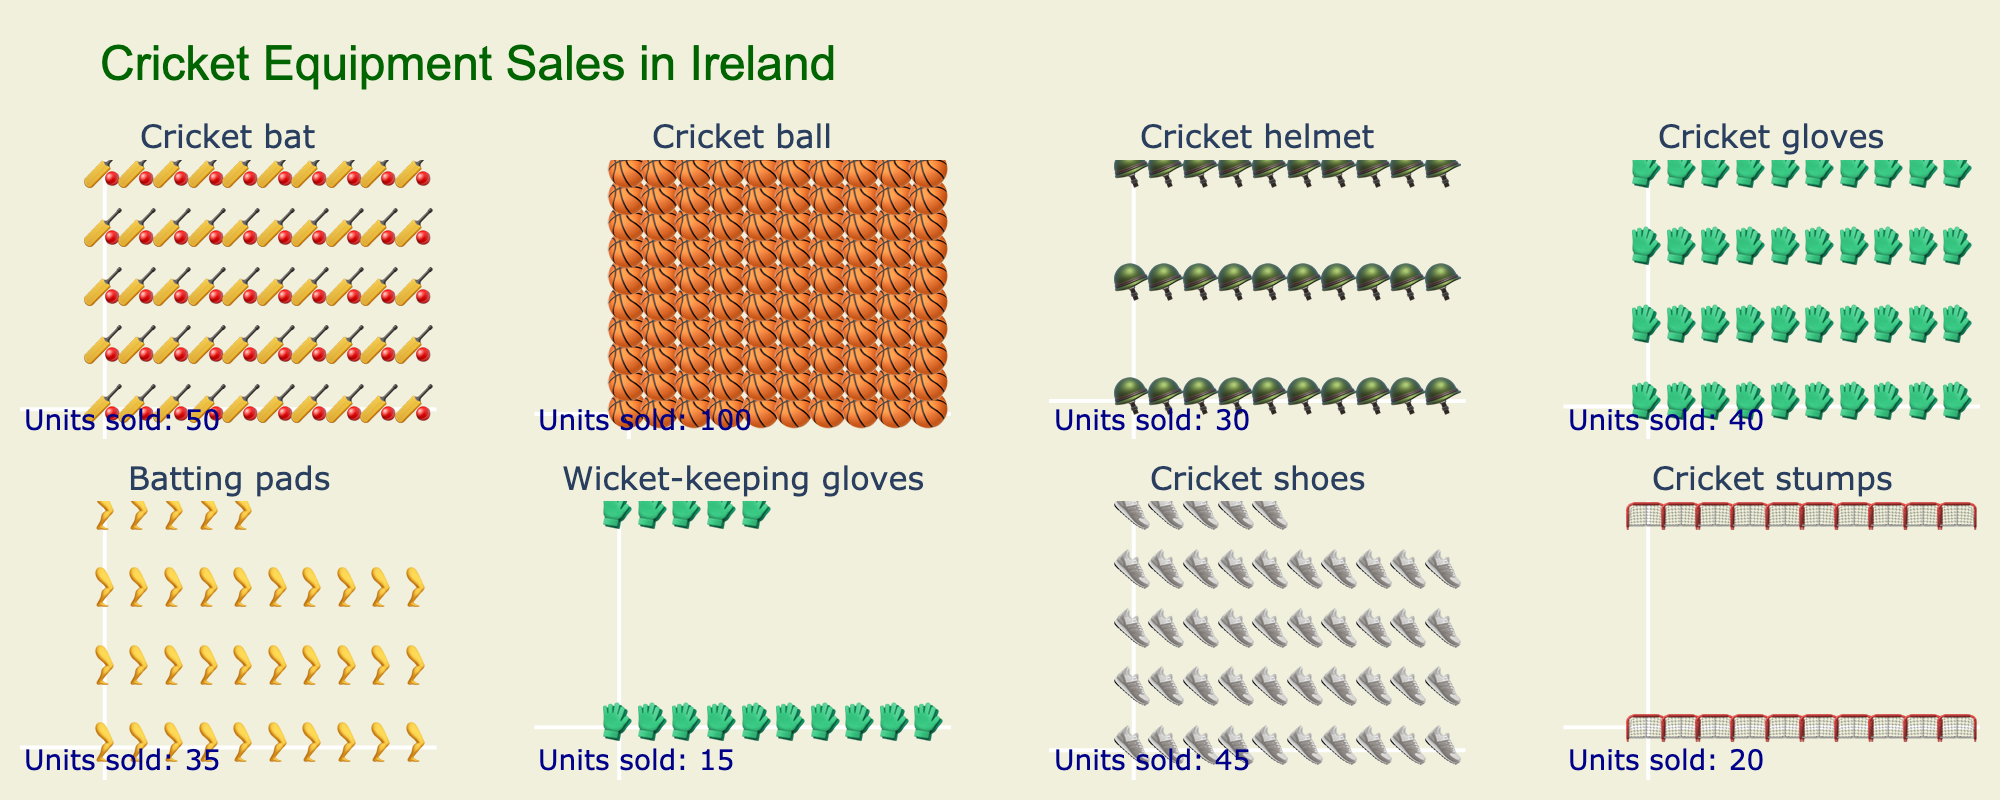Which equipment type sold the most units? The cricket equipment type with the most units sold can be determined by looking at the plot and identifying which has the highest count of icons.
Answer: Cricket ball How many units of cricket helmets were sold? Find the isotype plot segment for cricket helmets and count the number of icons shown.
Answer: 30 What's the total number of units sold for cricket bats and cricket balls combined? Add the units sold for cricket bats and cricket balls: 50 (bats) + 100 (balls) = 150.
Answer: 150 Which cricket equipment sold fewer units: cricket stumps or wicket-keeping gloves? Compare the number of icons representing the sales of cricket stumps and wicket-keeping gloves.
Answer: Wicket-keeping gloves How many more units of cricket gloves were sold compared to wicket-keeping gloves? Subtract the units sold for wicket-keeping gloves from the units sold for cricket gloves: 40 (gloves) - 15 (wicket-keeping gloves) = 25.
Answer: 25 What is the average number of units sold across all equipment types? Sum the units sold for all equipment types and divide by the number of equipment types: (50+100+30+40+35+15+45+20)/8 = 335/8 = 41.875.
Answer: 41.875 Which two types of equipment had the closest sales figures? Identify the equipment types with unit sales closest in value. Batting pads (35) and cricket shoes (45) have a difference of 10 units, which is the smallest difference.
Answer: Batting pads and cricket shoes Is there any equipment type that sold exactly half the units of cricket balls? Check each equipment type's units sold to see if any equal half of cricket balls' units (100/2 = 50). Cricket bats sold 50 units, which is exactly half of cricket balls' units.
Answer: Cricket bat What is the ratio of units sold for cricket shoes to cricket stumps? Divide the units sold for cricket shoes by the units sold for cricket stumps: 45 (shoes) / 20 (stumps) = 2.25.
Answer: 2.25 